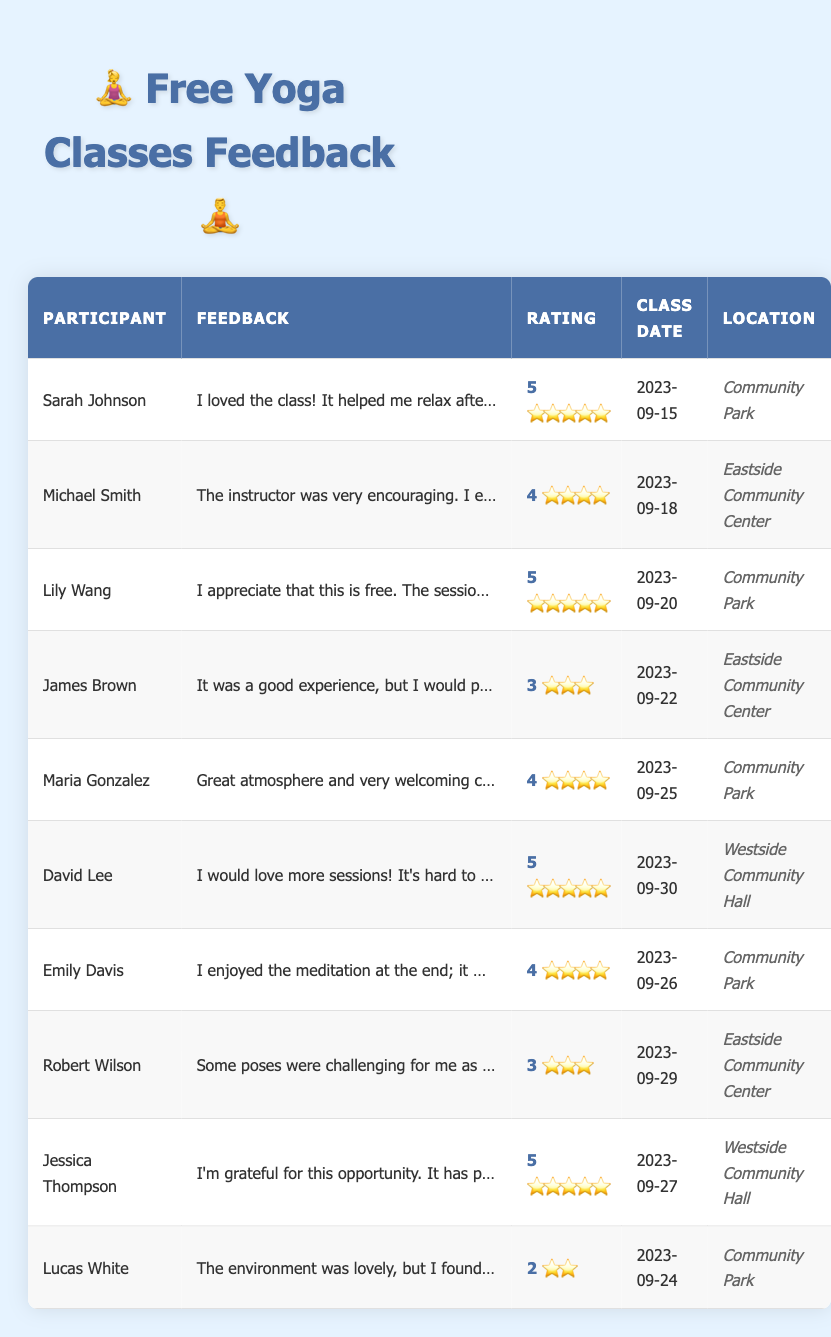What is the highest rating given by a participant? Looking through the ratings provided, the highest rating is 5, which was given by Sarah Johnson, Lily Wang, David Lee, and Jessica Thompson.
Answer: 5 What feedback did Michael Smith provide? Referring to the table, Michael Smith's feedback is, "The instructor was very encouraging. I enjoyed the flow of the class."
Answer: The instructor was very encouraging. I enjoyed the flow of the class How many participants rated the classes with a score of 3 or less? From the table, James Brown rated the class a 3, Robert Wilson also rated it a 3, and Lucas White rated it a 2. This gives us a total of 3 participants.
Answer: 3 Which participant appreciated the free classes? Looking at the feedback, Lily Wang specifically stated, "I appreciate that this is free. The session was rejuvenating."
Answer: Lily Wang What is the average rating for the classes? Adding the ratings: 5 + 4 + 5 + 3 + 4 + 5 + 4 + 3 + 5 + 2 = 46. Since there are 10 participants, the average rating is 46 divided by 10, which equals 4.6.
Answer: 4.6 Did any participant mention a desire for more classes? Checking the feedback, David Lee expressed a desire for more sessions, stating, "I would love more sessions! It's hard to find free classes like this."
Answer: Yes What percentage of participants rated the class with a score of 4 or higher? There are a total of 10 participants, and 6 rated the class 4 or higher (Sarah Johnson, Michael Smith, Lily Wang, Maria Gonzalez, David Lee, and Jessica Thompson). Calculating the percentage: (6/10) * 100 = 60%.
Answer: 60% What feedback did Jessica Thompson provide about her experience? According to the feedback in the table, Jessica Thompson's comment was, "I'm grateful for this opportunity. It has positively impacted my mental health."
Answer: I'm grateful for this opportunity. It has positively impacted my mental health Were the classes held at the same location? Analyzing the locations, the classes were held at Community Park, Eastside Community Center, and Westside Community Hall. Therefore, they were not all held at the same location.
Answer: No 